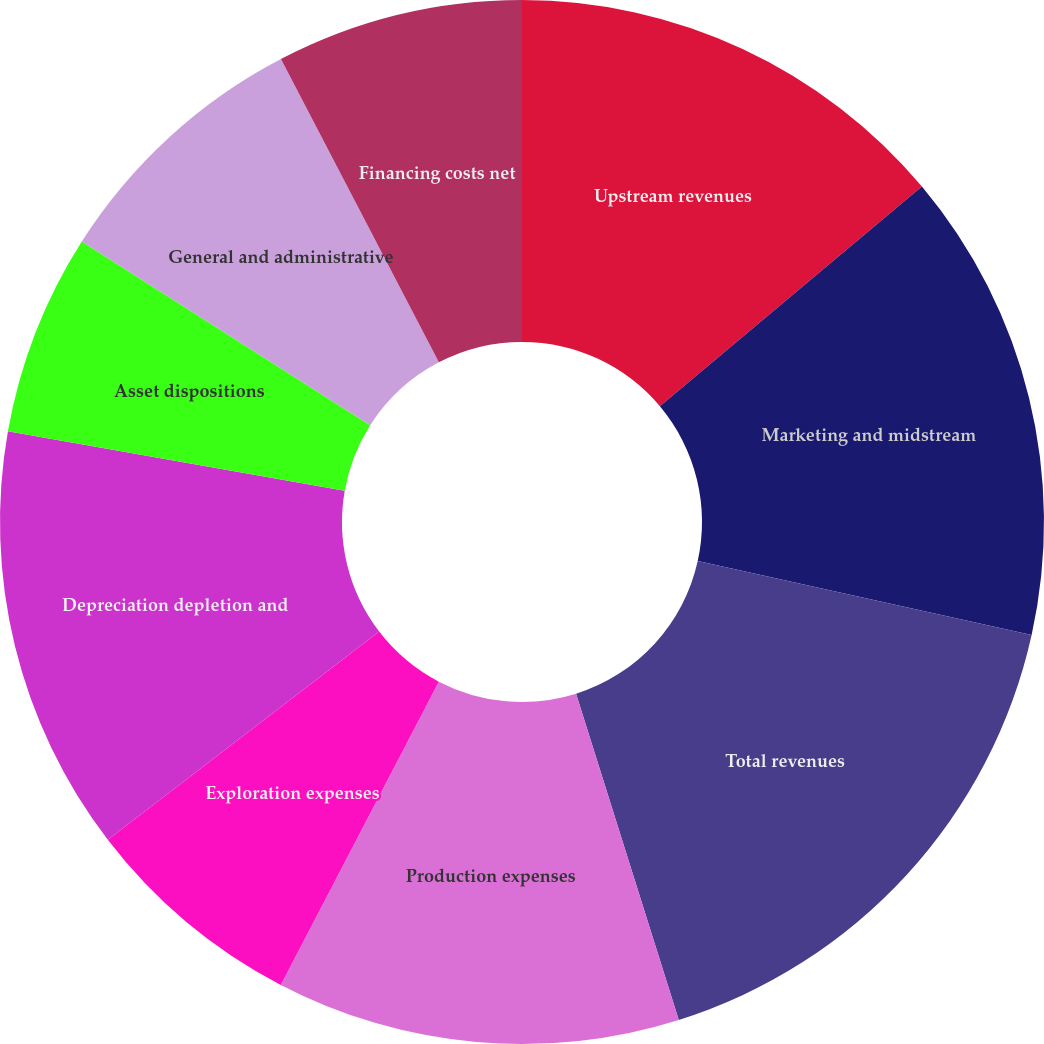<chart> <loc_0><loc_0><loc_500><loc_500><pie_chart><fcel>Upstream revenues<fcel>Marketing and midstream<fcel>Total revenues<fcel>Production expenses<fcel>Exploration expenses<fcel>Depreciation depletion and<fcel>Asset dispositions<fcel>General and administrative<fcel>Financing costs net<nl><fcel>13.89%<fcel>14.58%<fcel>16.67%<fcel>12.5%<fcel>6.94%<fcel>13.19%<fcel>6.25%<fcel>8.33%<fcel>7.64%<nl></chart> 